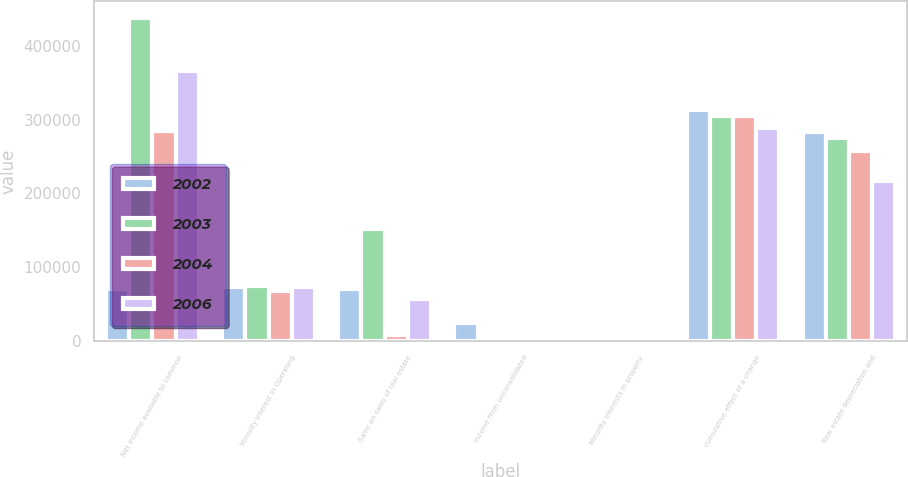Convert chart to OTSL. <chart><loc_0><loc_0><loc_500><loc_500><stacked_bar_chart><ecel><fcel>Net income available to common<fcel>Minority interest in Operating<fcel>Gains on sales of real estate<fcel>Income from unconsolidated<fcel>Minority interests in property<fcel>cumulative effect of a change<fcel>Real estate depreciation and<nl><fcel>2002<fcel>70236<fcel>72976<fcel>70236<fcel>24507<fcel>479<fcel>313697<fcel>283350<nl><fcel>2003<fcel>438292<fcel>74103<fcel>151884<fcel>4829<fcel>113<fcel>304324<fcel>274476<nl><fcel>2004<fcel>284017<fcel>67743<fcel>8149<fcel>3380<fcel>922<fcel>304864<fcel>257319<nl><fcel>2006<fcel>365322<fcel>72729<fcel>57574<fcel>6016<fcel>3458<fcel>288475<fcel>216235<nl></chart> 